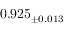Convert formula to latex. <formula><loc_0><loc_0><loc_500><loc_500>0 . 9 2 5 _ { \pm 0 . 0 1 3 }</formula> 